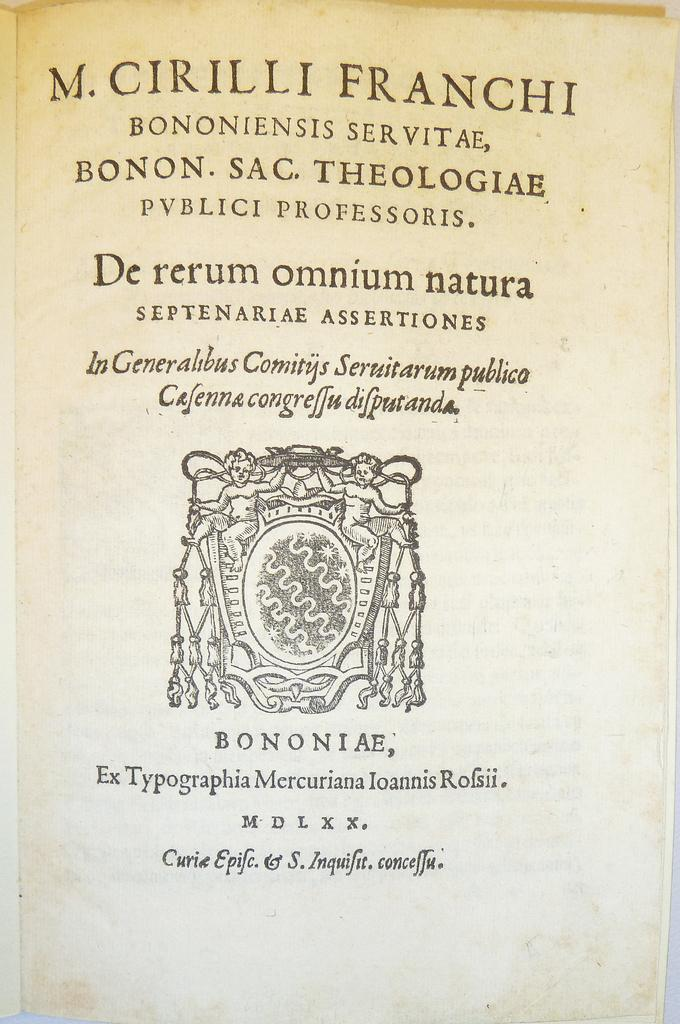<image>
Summarize the visual content of the image. The title page of a book which begins with "M. Cirilli Franchi" 